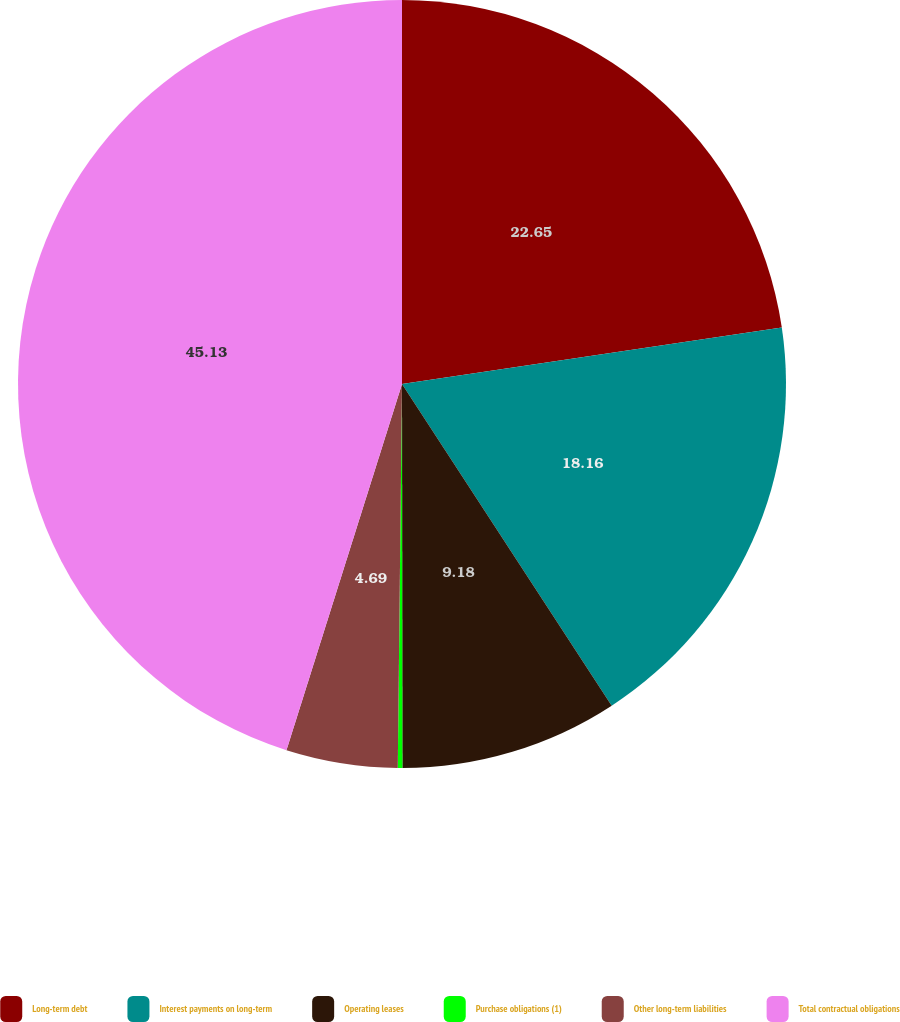<chart> <loc_0><loc_0><loc_500><loc_500><pie_chart><fcel>Long-term debt<fcel>Interest payments on long-term<fcel>Operating leases<fcel>Purchase obligations (1)<fcel>Other long-term liabilities<fcel>Total contractual obligations<nl><fcel>22.65%<fcel>18.16%<fcel>9.18%<fcel>0.19%<fcel>4.69%<fcel>45.14%<nl></chart> 